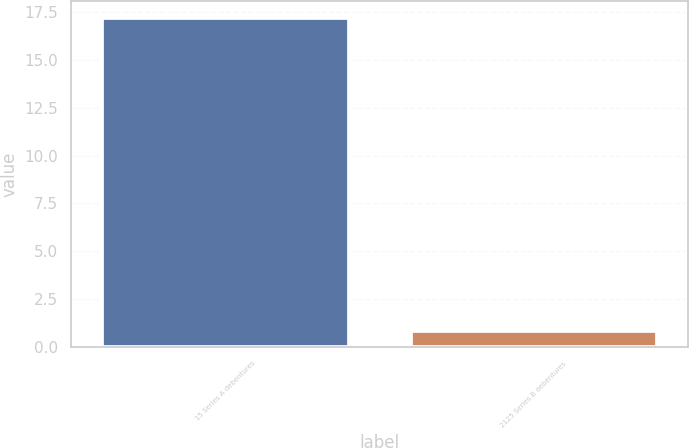Convert chart to OTSL. <chart><loc_0><loc_0><loc_500><loc_500><bar_chart><fcel>15 Series A debentures<fcel>2125 Series B debentures<nl><fcel>17.19<fcel>0.85<nl></chart> 